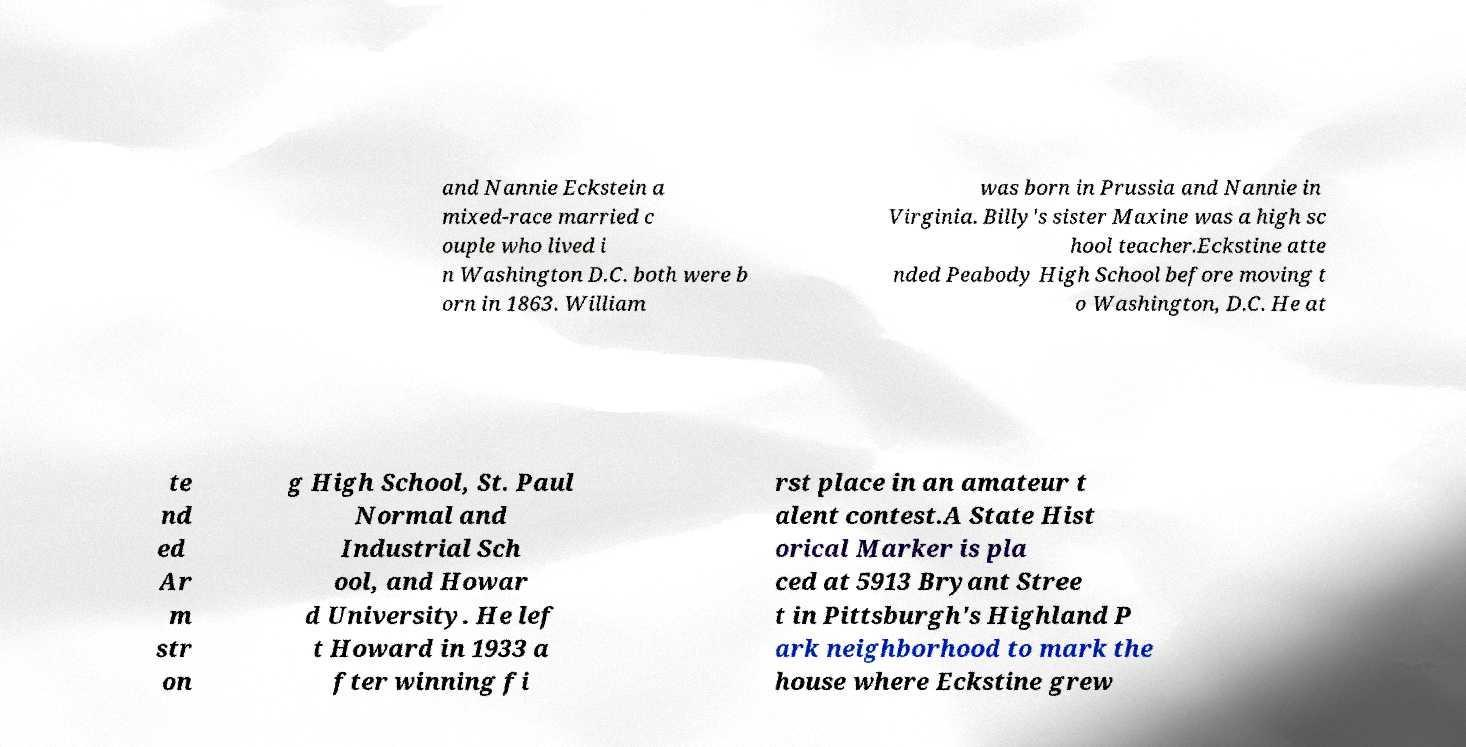Could you assist in decoding the text presented in this image and type it out clearly? and Nannie Eckstein a mixed-race married c ouple who lived i n Washington D.C. both were b orn in 1863. William was born in Prussia and Nannie in Virginia. Billy's sister Maxine was a high sc hool teacher.Eckstine atte nded Peabody High School before moving t o Washington, D.C. He at te nd ed Ar m str on g High School, St. Paul Normal and Industrial Sch ool, and Howar d University. He lef t Howard in 1933 a fter winning fi rst place in an amateur t alent contest.A State Hist orical Marker is pla ced at 5913 Bryant Stree t in Pittsburgh's Highland P ark neighborhood to mark the house where Eckstine grew 